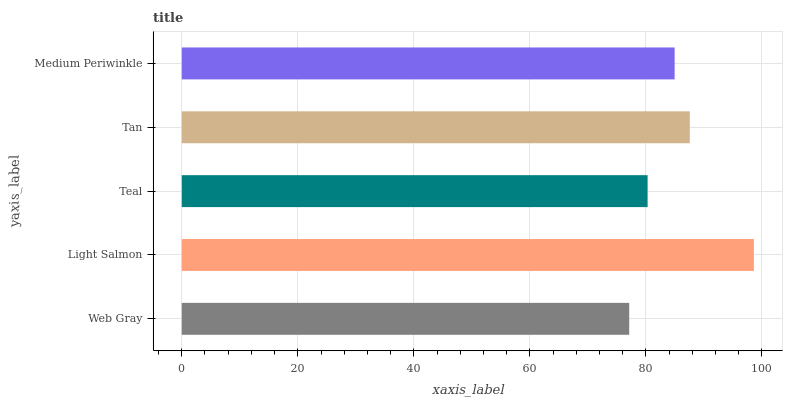Is Web Gray the minimum?
Answer yes or no. Yes. Is Light Salmon the maximum?
Answer yes or no. Yes. Is Teal the minimum?
Answer yes or no. No. Is Teal the maximum?
Answer yes or no. No. Is Light Salmon greater than Teal?
Answer yes or no. Yes. Is Teal less than Light Salmon?
Answer yes or no. Yes. Is Teal greater than Light Salmon?
Answer yes or no. No. Is Light Salmon less than Teal?
Answer yes or no. No. Is Medium Periwinkle the high median?
Answer yes or no. Yes. Is Medium Periwinkle the low median?
Answer yes or no. Yes. Is Light Salmon the high median?
Answer yes or no. No. Is Light Salmon the low median?
Answer yes or no. No. 